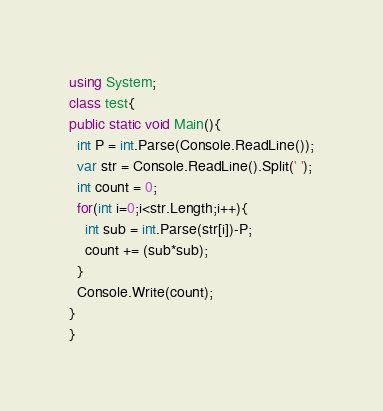Convert code to text. <code><loc_0><loc_0><loc_500><loc_500><_C#_>using System;
class test{
public static void Main(){
  int P = int.Parse(Console.ReadLine());
  var str = Console.ReadLine().Split(' ');
  int count = 0;
  for(int i=0;i<str.Length;i++){
    int sub = int.Parse(str[i])-P;
    count += (sub*sub);
  }
  Console.Write(count);
}
}</code> 